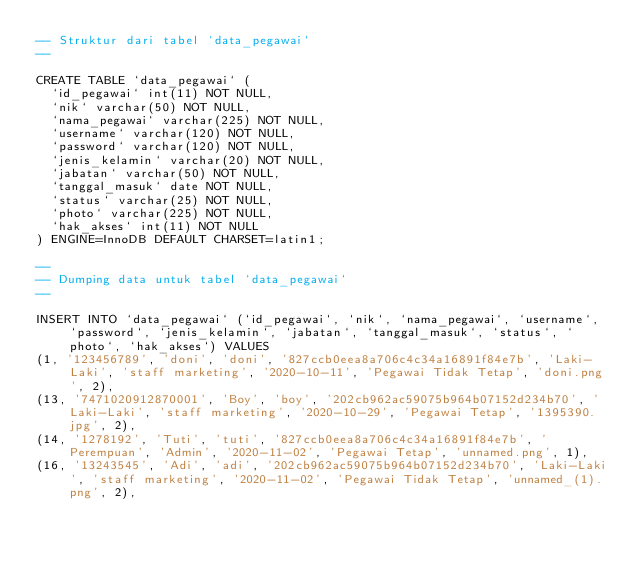<code> <loc_0><loc_0><loc_500><loc_500><_SQL_>-- Struktur dari tabel `data_pegawai`
--

CREATE TABLE `data_pegawai` (
  `id_pegawai` int(11) NOT NULL,
  `nik` varchar(50) NOT NULL,
  `nama_pegawai` varchar(225) NOT NULL,
  `username` varchar(120) NOT NULL,
  `password` varchar(120) NOT NULL,
  `jenis_kelamin` varchar(20) NOT NULL,
  `jabatan` varchar(50) NOT NULL,
  `tanggal_masuk` date NOT NULL,
  `status` varchar(25) NOT NULL,
  `photo` varchar(225) NOT NULL,
  `hak_akses` int(11) NOT NULL
) ENGINE=InnoDB DEFAULT CHARSET=latin1;

--
-- Dumping data untuk tabel `data_pegawai`
--

INSERT INTO `data_pegawai` (`id_pegawai`, `nik`, `nama_pegawai`, `username`, `password`, `jenis_kelamin`, `jabatan`, `tanggal_masuk`, `status`, `photo`, `hak_akses`) VALUES
(1, '123456789', 'doni', 'doni', '827ccb0eea8a706c4c34a16891f84e7b', 'Laki-Laki', 'staff marketing', '2020-10-11', 'Pegawai Tidak Tetap', 'doni.png', 2),
(13, '7471020912870001', 'Boy', 'boy', '202cb962ac59075b964b07152d234b70', 'Laki-Laki', 'staff marketing', '2020-10-29', 'Pegawai Tetap', '1395390.jpg', 2),
(14, '1278192', 'Tuti', 'tuti', '827ccb0eea8a706c4c34a16891f84e7b', 'Perempuan', 'Admin', '2020-11-02', 'Pegawai Tetap', 'unnamed.png', 1),
(16, '13243545', 'Adi', 'adi', '202cb962ac59075b964b07152d234b70', 'Laki-Laki', 'staff marketing', '2020-11-02', 'Pegawai Tidak Tetap', 'unnamed_(1).png', 2),</code> 